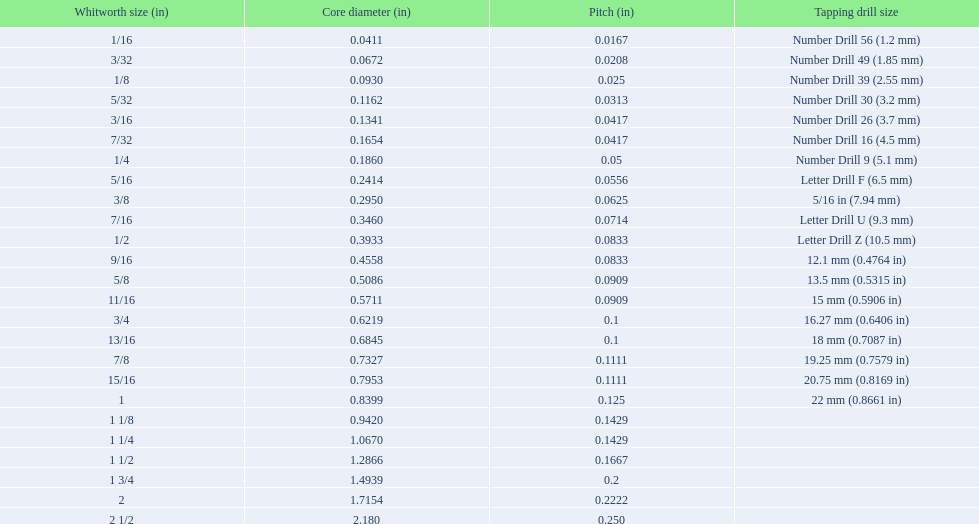What is the primary diameter of the last whitworth thread dimension? 2.180. 